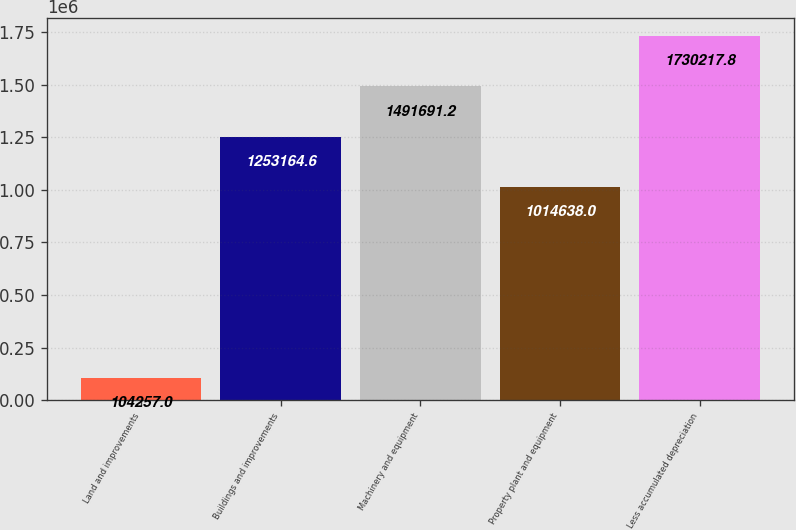Convert chart to OTSL. <chart><loc_0><loc_0><loc_500><loc_500><bar_chart><fcel>Land and improvements<fcel>Buildings and improvements<fcel>Machinery and equipment<fcel>Property plant and equipment<fcel>Less accumulated depreciation<nl><fcel>104257<fcel>1.25316e+06<fcel>1.49169e+06<fcel>1.01464e+06<fcel>1.73022e+06<nl></chart> 